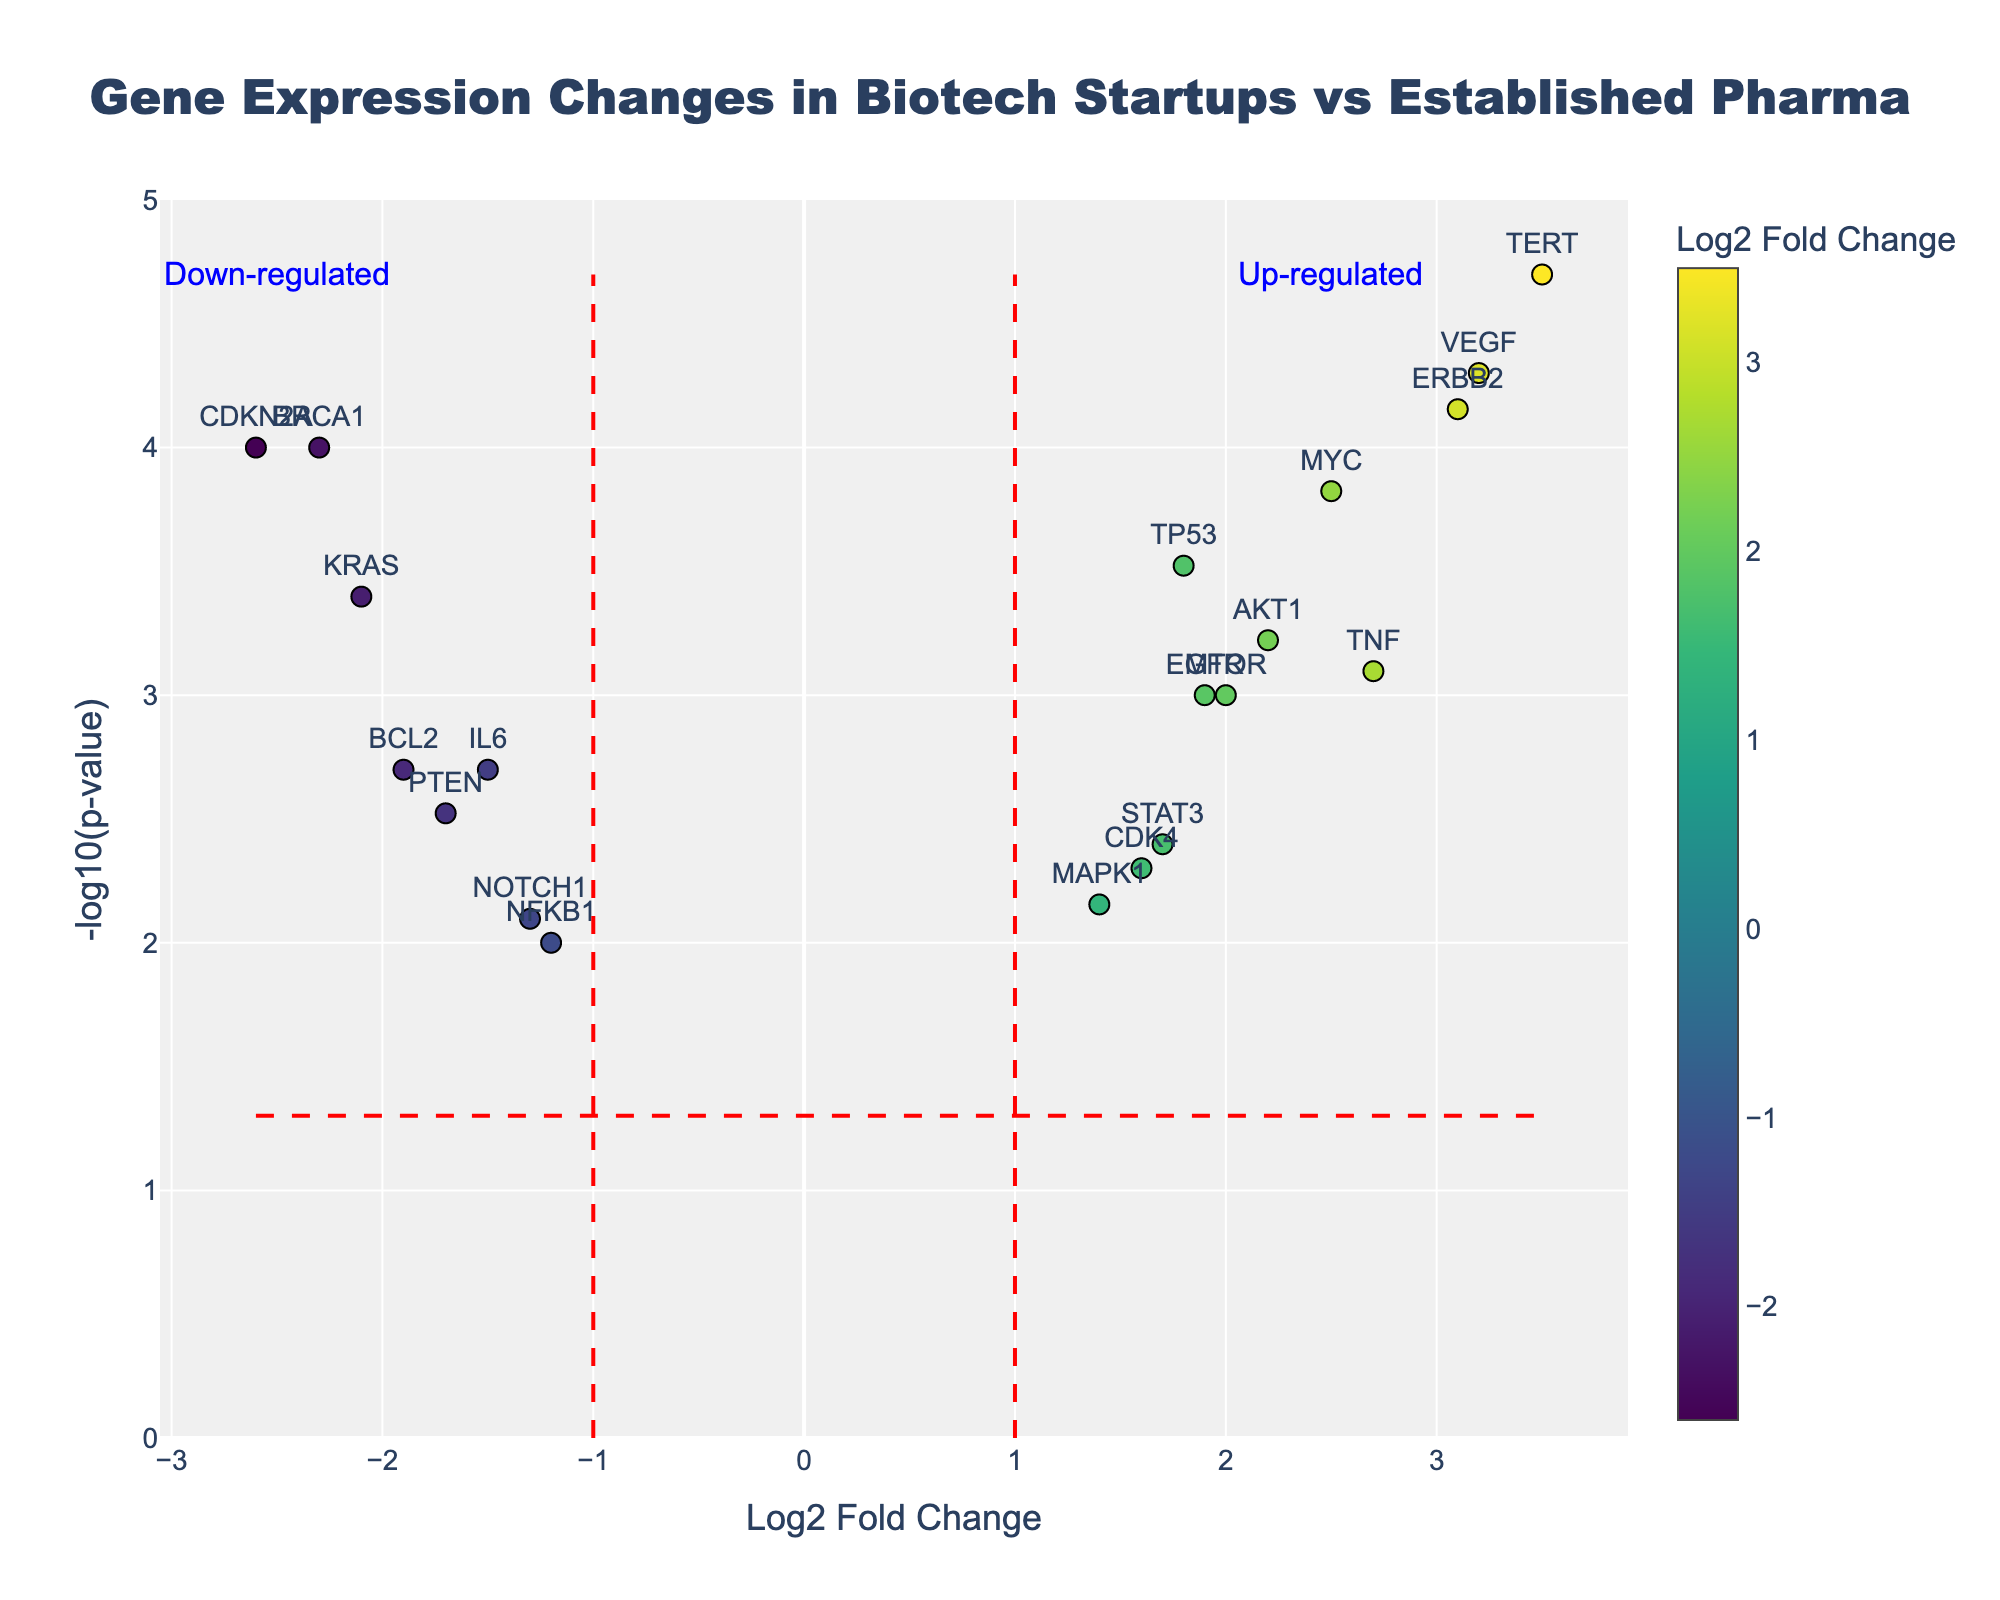What is the title of the plot? The title is displayed at the top of the plot in larger, bold text. It provides an overview of what the plot is about.
Answer: Gene Expression Changes in Biotech Startups vs Established Pharma Which gene has the highest log2 fold change? The plot displays data points marked with gene names. The gene with the highest log2 fold change will be the point farthest to the right on the x-axis.
Answer: TERT What is the y-axis label in the plot? The y-axis label can be found along the vertical axis of the plot.
Answer: -log10(p-value) Which genes fall within the up-regulated section? The up-regulated section of the plot is identified by positive log2 fold change values on the right side of the plot past the vertical dashed line (>1). The gene names in this section need to be observed.
Answer: TP53, VEGF, TNF, EGFR, MYC, AKT1, MTOR, ERBB2 How many genes have a p-value less than 0.005? To answer this, count the number of data points that appear above the horizontal dashed line representing -log10(0.005).
Answer: 12 Which down-regulated gene has the lowest p-value? Identify the down-regulated genes to the left of the log2 fold change line (<-1). Then, find the one with the highest y-axis position (highest -log10(p-value)).
Answer: BRCA1 Compare the log2 fold change values for VEGF and CDKN2A. Which one is higher? To find this, locate VEGF and CDKN2A on the plot and compare their horizontal positions.
Answer: VEGF Are there more up-regulated genes or down-regulated genes in this plot? Count the number of data points on the right side of the vertical log2 fold change line (>1 for up-regulated) and on the left side (<-1 for down-regulated).
Answer: More up-regulated genes What is the significance threshold for p-values shown in the plot? The significance threshold for p-values is presented as a horizontal dashed line, which corresponds to a specific -log10(p-value). The horizontal line corresponds to -log10(0.05).
Answer: 0.05 Which gene near the center is least likely to be significantly differentially expressed? The least significant genes will be near the bottom of the plot, closer to a y-axis value of 0. Look for the gene with the smallest -log10(p-value).
Answer: NFKB1 